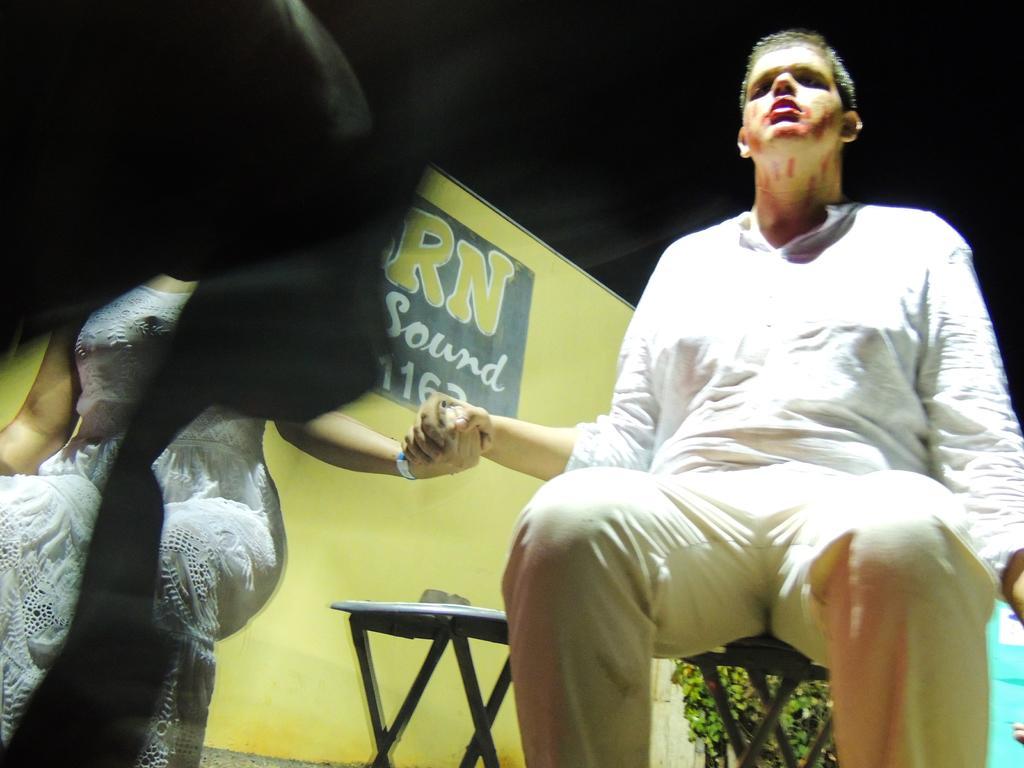How would you summarize this image in a sentence or two? In this image we can see two persons are sitting on the chairs. There is a hoarding, leaves, and a chair. There is a dark background. 